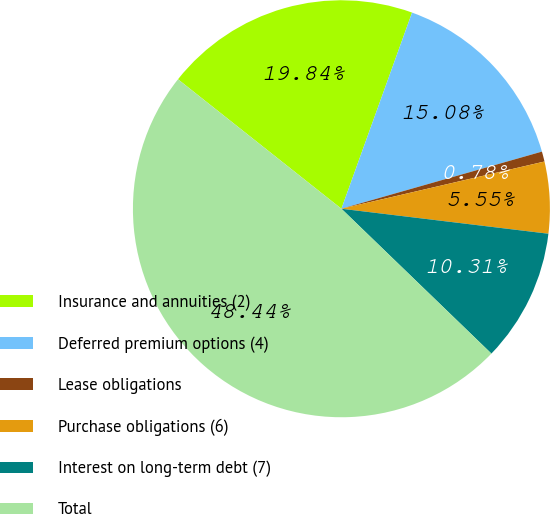Convert chart to OTSL. <chart><loc_0><loc_0><loc_500><loc_500><pie_chart><fcel>Insurance and annuities (2)<fcel>Deferred premium options (4)<fcel>Lease obligations<fcel>Purchase obligations (6)<fcel>Interest on long-term debt (7)<fcel>Total<nl><fcel>19.84%<fcel>15.08%<fcel>0.78%<fcel>5.55%<fcel>10.31%<fcel>48.44%<nl></chart> 